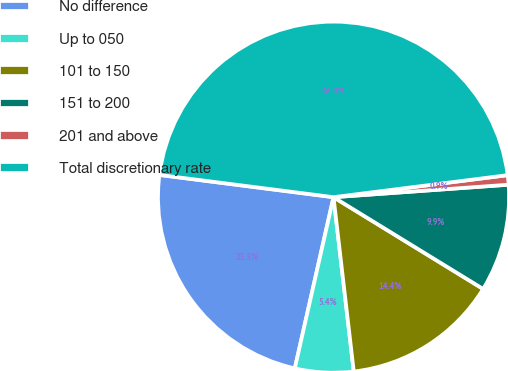<chart> <loc_0><loc_0><loc_500><loc_500><pie_chart><fcel>No difference<fcel>Up to 050<fcel>101 to 150<fcel>151 to 200<fcel>201 and above<fcel>Total discretionary rate<nl><fcel>23.48%<fcel>5.38%<fcel>14.4%<fcel>9.89%<fcel>0.87%<fcel>45.97%<nl></chart> 